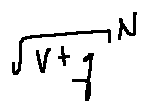Convert formula to latex. <formula><loc_0><loc_0><loc_500><loc_500>\sqrt { V + q } ^ { N }</formula> 